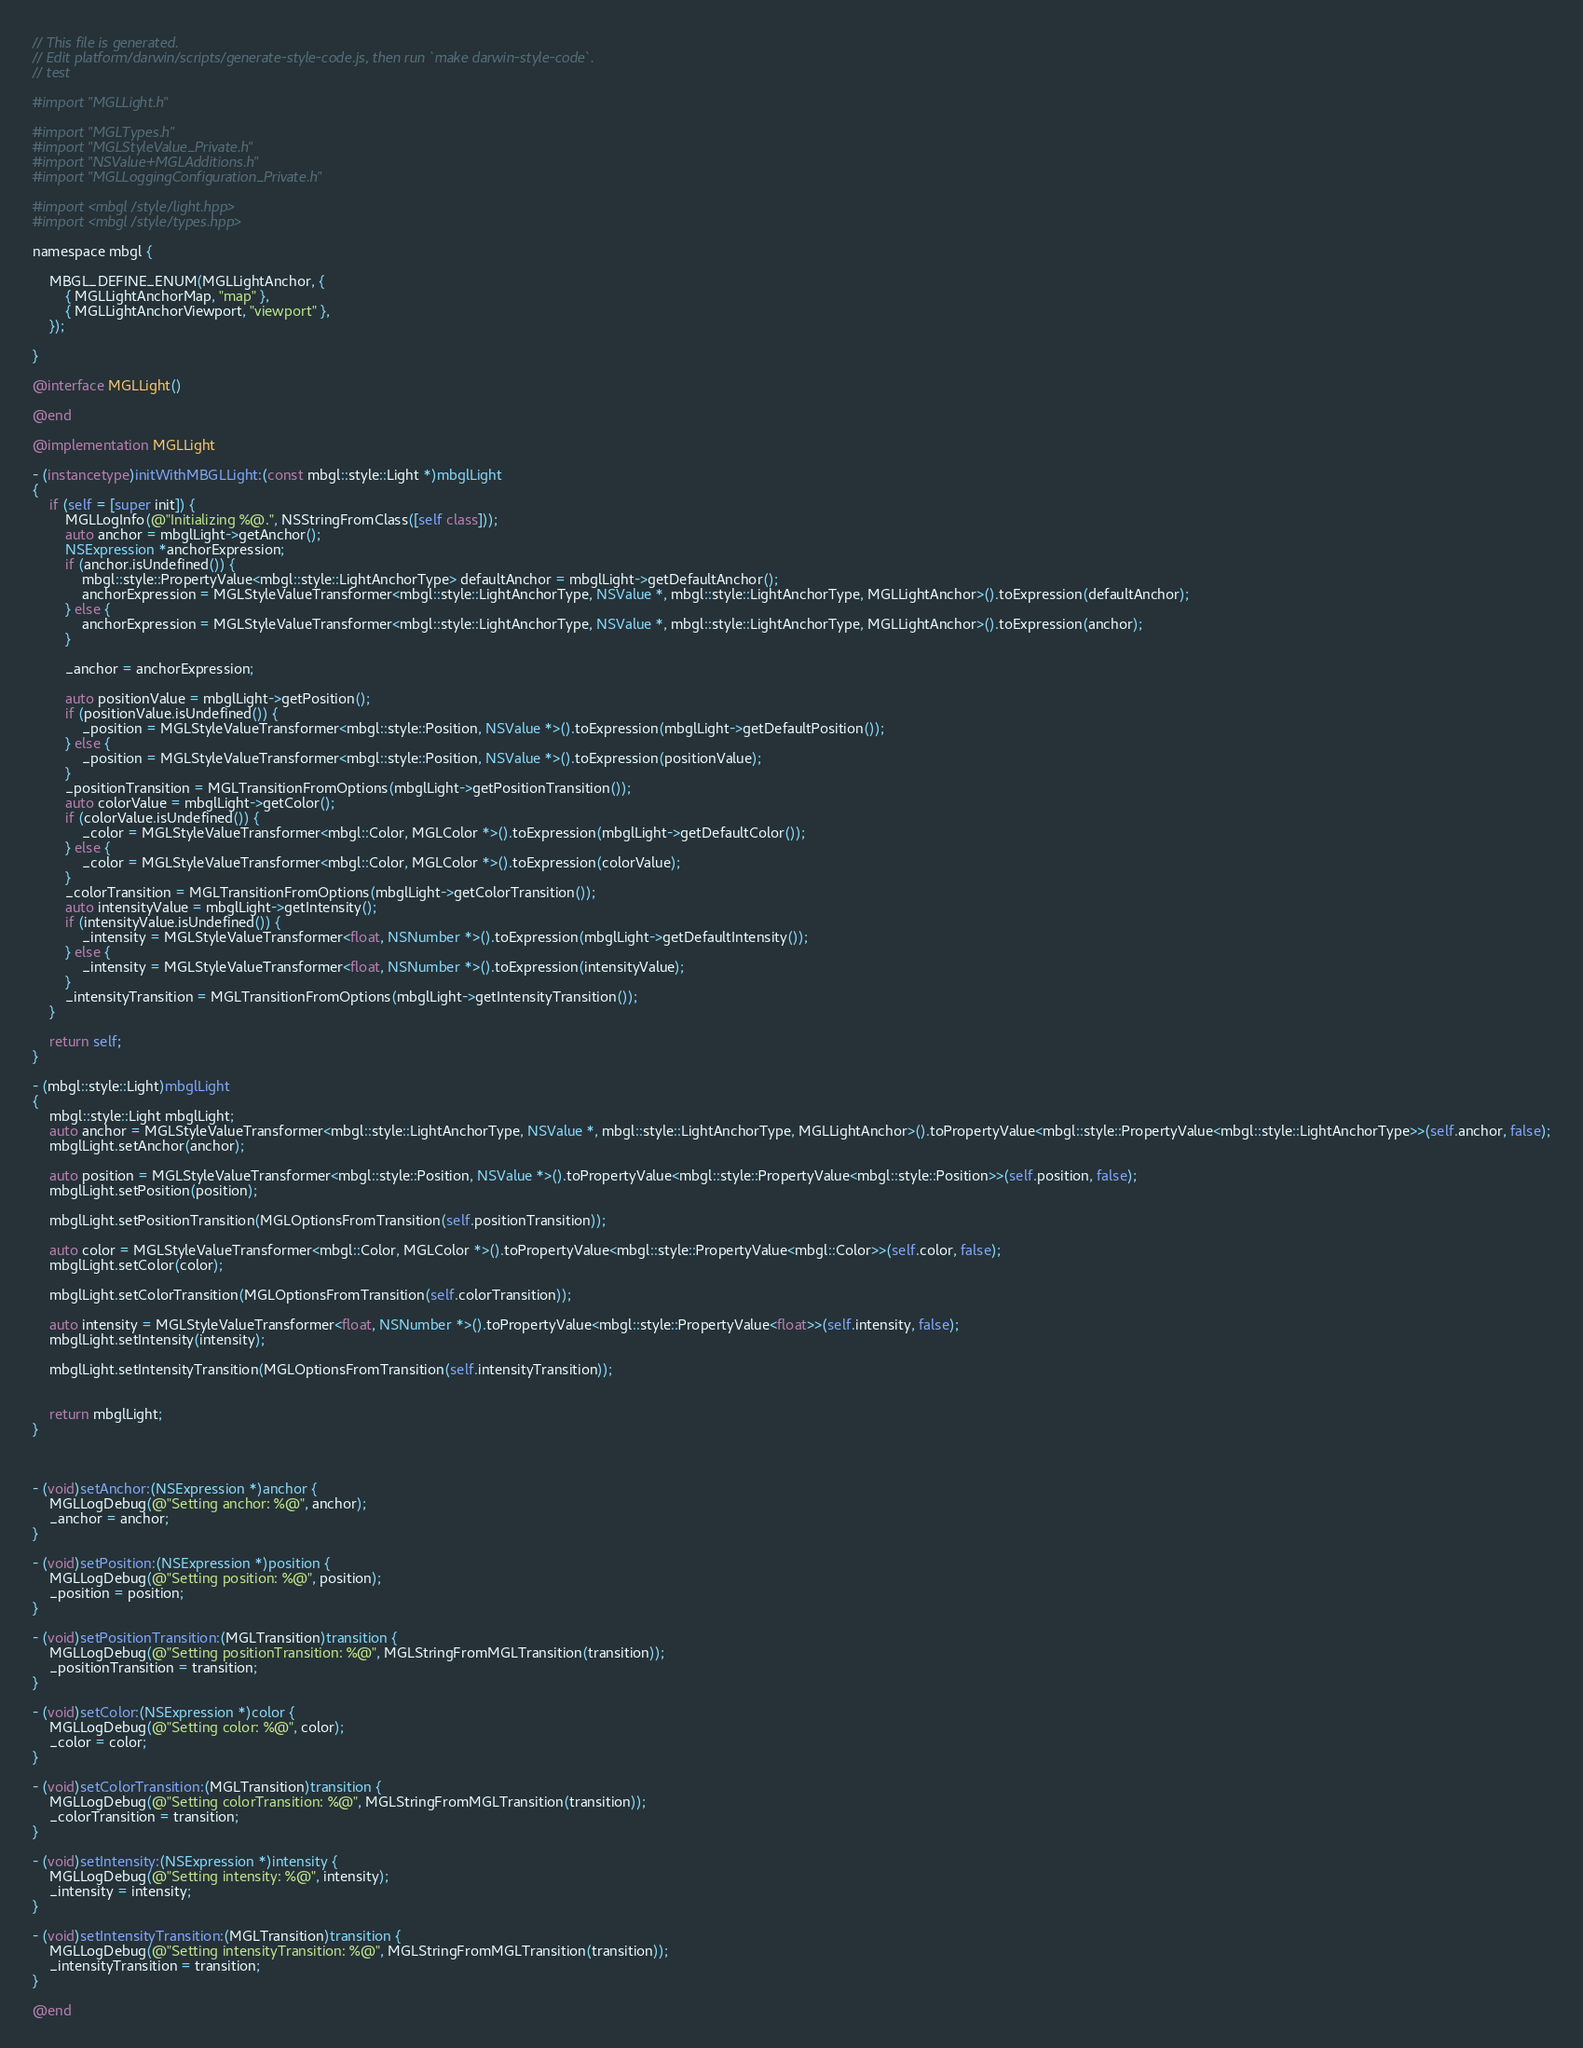<code> <loc_0><loc_0><loc_500><loc_500><_ObjectiveC_>// This file is generated.
// Edit platform/darwin/scripts/generate-style-code.js, then run `make darwin-style-code`.
// test

#import "MGLLight.h"

#import "MGLTypes.h"
#import "MGLStyleValue_Private.h"
#import "NSValue+MGLAdditions.h"
#import "MGLLoggingConfiguration_Private.h"

#import <mbgl/style/light.hpp>
#import <mbgl/style/types.hpp>

namespace mbgl {

    MBGL_DEFINE_ENUM(MGLLightAnchor, {
        { MGLLightAnchorMap, "map" },
        { MGLLightAnchorViewport, "viewport" },
    });

}

@interface MGLLight()

@end

@implementation MGLLight

- (instancetype)initWithMBGLLight:(const mbgl::style::Light *)mbglLight
{
    if (self = [super init]) {
        MGLLogInfo(@"Initializing %@.", NSStringFromClass([self class]));
        auto anchor = mbglLight->getAnchor();
        NSExpression *anchorExpression;
        if (anchor.isUndefined()) {
            mbgl::style::PropertyValue<mbgl::style::LightAnchorType> defaultAnchor = mbglLight->getDefaultAnchor();
            anchorExpression = MGLStyleValueTransformer<mbgl::style::LightAnchorType, NSValue *, mbgl::style::LightAnchorType, MGLLightAnchor>().toExpression(defaultAnchor);
        } else {
            anchorExpression = MGLStyleValueTransformer<mbgl::style::LightAnchorType, NSValue *, mbgl::style::LightAnchorType, MGLLightAnchor>().toExpression(anchor);
        }

        _anchor = anchorExpression;

        auto positionValue = mbglLight->getPosition();
        if (positionValue.isUndefined()) {
            _position = MGLStyleValueTransformer<mbgl::style::Position, NSValue *>().toExpression(mbglLight->getDefaultPosition());
        } else {
            _position = MGLStyleValueTransformer<mbgl::style::Position, NSValue *>().toExpression(positionValue);
        }
        _positionTransition = MGLTransitionFromOptions(mbglLight->getPositionTransition());
        auto colorValue = mbglLight->getColor();
        if (colorValue.isUndefined()) {
            _color = MGLStyleValueTransformer<mbgl::Color, MGLColor *>().toExpression(mbglLight->getDefaultColor());
        } else {
            _color = MGLStyleValueTransformer<mbgl::Color, MGLColor *>().toExpression(colorValue);
        }
        _colorTransition = MGLTransitionFromOptions(mbglLight->getColorTransition());
        auto intensityValue = mbglLight->getIntensity();
        if (intensityValue.isUndefined()) {
            _intensity = MGLStyleValueTransformer<float, NSNumber *>().toExpression(mbglLight->getDefaultIntensity());
        } else {
            _intensity = MGLStyleValueTransformer<float, NSNumber *>().toExpression(intensityValue);
        }
        _intensityTransition = MGLTransitionFromOptions(mbglLight->getIntensityTransition());
    }

    return self;
}

- (mbgl::style::Light)mbglLight
{
    mbgl::style::Light mbglLight;
    auto anchor = MGLStyleValueTransformer<mbgl::style::LightAnchorType, NSValue *, mbgl::style::LightAnchorType, MGLLightAnchor>().toPropertyValue<mbgl::style::PropertyValue<mbgl::style::LightAnchorType>>(self.anchor, false);
    mbglLight.setAnchor(anchor);

    auto position = MGLStyleValueTransformer<mbgl::style::Position, NSValue *>().toPropertyValue<mbgl::style::PropertyValue<mbgl::style::Position>>(self.position, false);
    mbglLight.setPosition(position);

    mbglLight.setPositionTransition(MGLOptionsFromTransition(self.positionTransition));

    auto color = MGLStyleValueTransformer<mbgl::Color, MGLColor *>().toPropertyValue<mbgl::style::PropertyValue<mbgl::Color>>(self.color, false);
    mbglLight.setColor(color);

    mbglLight.setColorTransition(MGLOptionsFromTransition(self.colorTransition));

    auto intensity = MGLStyleValueTransformer<float, NSNumber *>().toPropertyValue<mbgl::style::PropertyValue<float>>(self.intensity, false);
    mbglLight.setIntensity(intensity);

    mbglLight.setIntensityTransition(MGLOptionsFromTransition(self.intensityTransition));


    return mbglLight;
}



- (void)setAnchor:(NSExpression *)anchor {
    MGLLogDebug(@"Setting anchor: %@", anchor);
    _anchor = anchor;
}

- (void)setPosition:(NSExpression *)position {
    MGLLogDebug(@"Setting position: %@", position);
    _position = position;
}

- (void)setPositionTransition:(MGLTransition)transition {
    MGLLogDebug(@"Setting positionTransition: %@", MGLStringFromMGLTransition(transition));
    _positionTransition = transition;
}

- (void)setColor:(NSExpression *)color {
    MGLLogDebug(@"Setting color: %@", color);
    _color = color;
}

- (void)setColorTransition:(MGLTransition)transition {
    MGLLogDebug(@"Setting colorTransition: %@", MGLStringFromMGLTransition(transition));
    _colorTransition = transition;
}

- (void)setIntensity:(NSExpression *)intensity {
    MGLLogDebug(@"Setting intensity: %@", intensity);
    _intensity = intensity;
}

- (void)setIntensityTransition:(MGLTransition)transition {
    MGLLogDebug(@"Setting intensityTransition: %@", MGLStringFromMGLTransition(transition));
    _intensityTransition = transition;
}

@end
</code> 